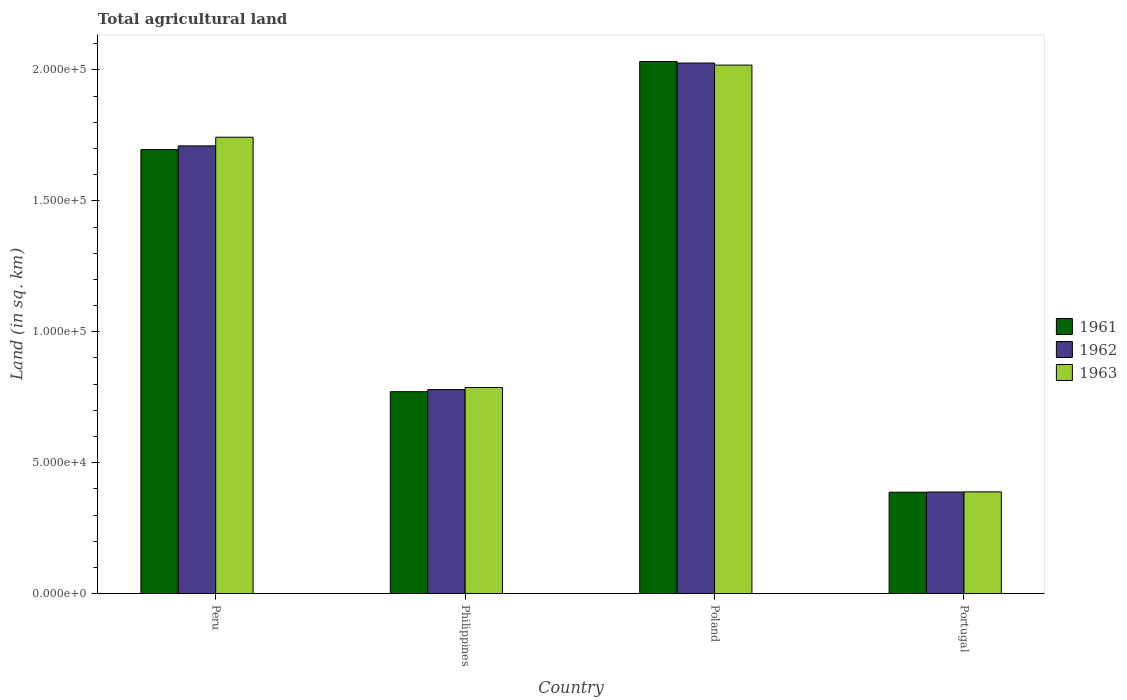How many different coloured bars are there?
Your answer should be very brief. 3. How many groups of bars are there?
Provide a succinct answer. 4. How many bars are there on the 3rd tick from the left?
Offer a terse response. 3. How many bars are there on the 4th tick from the right?
Keep it short and to the point. 3. What is the label of the 4th group of bars from the left?
Offer a very short reply. Portugal. In how many cases, is the number of bars for a given country not equal to the number of legend labels?
Ensure brevity in your answer.  0. What is the total agricultural land in 1963 in Philippines?
Offer a very short reply. 7.87e+04. Across all countries, what is the maximum total agricultural land in 1961?
Keep it short and to the point. 2.03e+05. Across all countries, what is the minimum total agricultural land in 1963?
Make the answer very short. 3.89e+04. In which country was the total agricultural land in 1962 minimum?
Your answer should be compact. Portugal. What is the total total agricultural land in 1961 in the graph?
Offer a terse response. 4.89e+05. What is the difference between the total agricultural land in 1962 in Philippines and that in Poland?
Keep it short and to the point. -1.25e+05. What is the difference between the total agricultural land in 1962 in Portugal and the total agricultural land in 1961 in Philippines?
Make the answer very short. -3.83e+04. What is the average total agricultural land in 1962 per country?
Ensure brevity in your answer.  1.23e+05. What is the difference between the total agricultural land of/in 1961 and total agricultural land of/in 1962 in Philippines?
Offer a very short reply. -790. What is the ratio of the total agricultural land in 1961 in Peru to that in Philippines?
Ensure brevity in your answer.  2.2. Is the difference between the total agricultural land in 1961 in Peru and Philippines greater than the difference between the total agricultural land in 1962 in Peru and Philippines?
Make the answer very short. No. What is the difference between the highest and the second highest total agricultural land in 1961?
Offer a very short reply. 9.24e+04. What is the difference between the highest and the lowest total agricultural land in 1961?
Your response must be concise. 1.64e+05. In how many countries, is the total agricultural land in 1961 greater than the average total agricultural land in 1961 taken over all countries?
Provide a short and direct response. 2. What does the 3rd bar from the right in Portugal represents?
Provide a short and direct response. 1961. Is it the case that in every country, the sum of the total agricultural land in 1961 and total agricultural land in 1962 is greater than the total agricultural land in 1963?
Make the answer very short. Yes. How many countries are there in the graph?
Ensure brevity in your answer.  4. Does the graph contain any zero values?
Provide a short and direct response. No. Does the graph contain grids?
Your answer should be very brief. No. What is the title of the graph?
Provide a succinct answer. Total agricultural land. What is the label or title of the Y-axis?
Your answer should be compact. Land (in sq. km). What is the Land (in sq. km) in 1961 in Peru?
Provide a short and direct response. 1.70e+05. What is the Land (in sq. km) in 1962 in Peru?
Provide a short and direct response. 1.71e+05. What is the Land (in sq. km) of 1963 in Peru?
Provide a succinct answer. 1.74e+05. What is the Land (in sq. km) in 1961 in Philippines?
Your answer should be very brief. 7.71e+04. What is the Land (in sq. km) of 1962 in Philippines?
Keep it short and to the point. 7.79e+04. What is the Land (in sq. km) of 1963 in Philippines?
Give a very brief answer. 7.87e+04. What is the Land (in sq. km) of 1961 in Poland?
Make the answer very short. 2.03e+05. What is the Land (in sq. km) in 1962 in Poland?
Provide a succinct answer. 2.03e+05. What is the Land (in sq. km) in 1963 in Poland?
Ensure brevity in your answer.  2.02e+05. What is the Land (in sq. km) in 1961 in Portugal?
Offer a very short reply. 3.88e+04. What is the Land (in sq. km) of 1962 in Portugal?
Your answer should be compact. 3.88e+04. What is the Land (in sq. km) in 1963 in Portugal?
Make the answer very short. 3.89e+04. Across all countries, what is the maximum Land (in sq. km) of 1961?
Provide a short and direct response. 2.03e+05. Across all countries, what is the maximum Land (in sq. km) in 1962?
Provide a short and direct response. 2.03e+05. Across all countries, what is the maximum Land (in sq. km) of 1963?
Provide a succinct answer. 2.02e+05. Across all countries, what is the minimum Land (in sq. km) of 1961?
Provide a short and direct response. 3.88e+04. Across all countries, what is the minimum Land (in sq. km) in 1962?
Provide a short and direct response. 3.88e+04. Across all countries, what is the minimum Land (in sq. km) in 1963?
Offer a terse response. 3.89e+04. What is the total Land (in sq. km) of 1961 in the graph?
Provide a succinct answer. 4.89e+05. What is the total Land (in sq. km) in 1962 in the graph?
Offer a very short reply. 4.90e+05. What is the total Land (in sq. km) in 1963 in the graph?
Your answer should be compact. 4.94e+05. What is the difference between the Land (in sq. km) in 1961 in Peru and that in Philippines?
Provide a succinct answer. 9.24e+04. What is the difference between the Land (in sq. km) in 1962 in Peru and that in Philippines?
Your response must be concise. 9.31e+04. What is the difference between the Land (in sq. km) in 1963 in Peru and that in Philippines?
Offer a terse response. 9.56e+04. What is the difference between the Land (in sq. km) of 1961 in Peru and that in Poland?
Give a very brief answer. -3.37e+04. What is the difference between the Land (in sq. km) of 1962 in Peru and that in Poland?
Make the answer very short. -3.16e+04. What is the difference between the Land (in sq. km) of 1963 in Peru and that in Poland?
Your answer should be compact. -2.75e+04. What is the difference between the Land (in sq. km) in 1961 in Peru and that in Portugal?
Your answer should be compact. 1.31e+05. What is the difference between the Land (in sq. km) in 1962 in Peru and that in Portugal?
Keep it short and to the point. 1.32e+05. What is the difference between the Land (in sq. km) of 1963 in Peru and that in Portugal?
Your answer should be compact. 1.35e+05. What is the difference between the Land (in sq. km) in 1961 in Philippines and that in Poland?
Keep it short and to the point. -1.26e+05. What is the difference between the Land (in sq. km) of 1962 in Philippines and that in Poland?
Provide a succinct answer. -1.25e+05. What is the difference between the Land (in sq. km) in 1963 in Philippines and that in Poland?
Ensure brevity in your answer.  -1.23e+05. What is the difference between the Land (in sq. km) in 1961 in Philippines and that in Portugal?
Keep it short and to the point. 3.84e+04. What is the difference between the Land (in sq. km) of 1962 in Philippines and that in Portugal?
Offer a very short reply. 3.91e+04. What is the difference between the Land (in sq. km) in 1963 in Philippines and that in Portugal?
Your response must be concise. 3.98e+04. What is the difference between the Land (in sq. km) in 1961 in Poland and that in Portugal?
Your answer should be very brief. 1.64e+05. What is the difference between the Land (in sq. km) in 1962 in Poland and that in Portugal?
Make the answer very short. 1.64e+05. What is the difference between the Land (in sq. km) in 1963 in Poland and that in Portugal?
Make the answer very short. 1.63e+05. What is the difference between the Land (in sq. km) of 1961 in Peru and the Land (in sq. km) of 1962 in Philippines?
Your response must be concise. 9.16e+04. What is the difference between the Land (in sq. km) in 1961 in Peru and the Land (in sq. km) in 1963 in Philippines?
Offer a terse response. 9.08e+04. What is the difference between the Land (in sq. km) in 1962 in Peru and the Land (in sq. km) in 1963 in Philippines?
Your answer should be very brief. 9.23e+04. What is the difference between the Land (in sq. km) of 1961 in Peru and the Land (in sq. km) of 1962 in Poland?
Give a very brief answer. -3.31e+04. What is the difference between the Land (in sq. km) in 1961 in Peru and the Land (in sq. km) in 1963 in Poland?
Your answer should be compact. -3.23e+04. What is the difference between the Land (in sq. km) in 1962 in Peru and the Land (in sq. km) in 1963 in Poland?
Offer a very short reply. -3.08e+04. What is the difference between the Land (in sq. km) of 1961 in Peru and the Land (in sq. km) of 1962 in Portugal?
Provide a succinct answer. 1.31e+05. What is the difference between the Land (in sq. km) in 1961 in Peru and the Land (in sq. km) in 1963 in Portugal?
Give a very brief answer. 1.31e+05. What is the difference between the Land (in sq. km) in 1962 in Peru and the Land (in sq. km) in 1963 in Portugal?
Give a very brief answer. 1.32e+05. What is the difference between the Land (in sq. km) in 1961 in Philippines and the Land (in sq. km) in 1962 in Poland?
Keep it short and to the point. -1.25e+05. What is the difference between the Land (in sq. km) of 1961 in Philippines and the Land (in sq. km) of 1963 in Poland?
Keep it short and to the point. -1.25e+05. What is the difference between the Land (in sq. km) of 1962 in Philippines and the Land (in sq. km) of 1963 in Poland?
Provide a succinct answer. -1.24e+05. What is the difference between the Land (in sq. km) of 1961 in Philippines and the Land (in sq. km) of 1962 in Portugal?
Give a very brief answer. 3.83e+04. What is the difference between the Land (in sq. km) in 1961 in Philippines and the Land (in sq. km) in 1963 in Portugal?
Your answer should be compact. 3.83e+04. What is the difference between the Land (in sq. km) in 1962 in Philippines and the Land (in sq. km) in 1963 in Portugal?
Give a very brief answer. 3.90e+04. What is the difference between the Land (in sq. km) in 1961 in Poland and the Land (in sq. km) in 1962 in Portugal?
Your answer should be very brief. 1.64e+05. What is the difference between the Land (in sq. km) in 1961 in Poland and the Land (in sq. km) in 1963 in Portugal?
Your answer should be compact. 1.64e+05. What is the difference between the Land (in sq. km) in 1962 in Poland and the Land (in sq. km) in 1963 in Portugal?
Your answer should be very brief. 1.64e+05. What is the average Land (in sq. km) in 1961 per country?
Your answer should be very brief. 1.22e+05. What is the average Land (in sq. km) of 1962 per country?
Make the answer very short. 1.23e+05. What is the average Land (in sq. km) in 1963 per country?
Provide a succinct answer. 1.23e+05. What is the difference between the Land (in sq. km) of 1961 and Land (in sq. km) of 1962 in Peru?
Make the answer very short. -1430. What is the difference between the Land (in sq. km) in 1961 and Land (in sq. km) in 1963 in Peru?
Ensure brevity in your answer.  -4740. What is the difference between the Land (in sq. km) of 1962 and Land (in sq. km) of 1963 in Peru?
Keep it short and to the point. -3310. What is the difference between the Land (in sq. km) in 1961 and Land (in sq. km) in 1962 in Philippines?
Keep it short and to the point. -790. What is the difference between the Land (in sq. km) of 1961 and Land (in sq. km) of 1963 in Philippines?
Your answer should be compact. -1590. What is the difference between the Land (in sq. km) of 1962 and Land (in sq. km) of 1963 in Philippines?
Your answer should be very brief. -800. What is the difference between the Land (in sq. km) of 1961 and Land (in sq. km) of 1962 in Poland?
Your response must be concise. 600. What is the difference between the Land (in sq. km) of 1961 and Land (in sq. km) of 1963 in Poland?
Your response must be concise. 1380. What is the difference between the Land (in sq. km) of 1962 and Land (in sq. km) of 1963 in Poland?
Keep it short and to the point. 780. What is the difference between the Land (in sq. km) of 1961 and Land (in sq. km) of 1962 in Portugal?
Ensure brevity in your answer.  -60. What is the difference between the Land (in sq. km) of 1961 and Land (in sq. km) of 1963 in Portugal?
Your answer should be compact. -120. What is the difference between the Land (in sq. km) of 1962 and Land (in sq. km) of 1963 in Portugal?
Your response must be concise. -60. What is the ratio of the Land (in sq. km) of 1961 in Peru to that in Philippines?
Make the answer very short. 2.2. What is the ratio of the Land (in sq. km) in 1962 in Peru to that in Philippines?
Ensure brevity in your answer.  2.19. What is the ratio of the Land (in sq. km) in 1963 in Peru to that in Philippines?
Keep it short and to the point. 2.21. What is the ratio of the Land (in sq. km) in 1961 in Peru to that in Poland?
Give a very brief answer. 0.83. What is the ratio of the Land (in sq. km) of 1962 in Peru to that in Poland?
Give a very brief answer. 0.84. What is the ratio of the Land (in sq. km) of 1963 in Peru to that in Poland?
Keep it short and to the point. 0.86. What is the ratio of the Land (in sq. km) of 1961 in Peru to that in Portugal?
Your answer should be very brief. 4.38. What is the ratio of the Land (in sq. km) of 1962 in Peru to that in Portugal?
Offer a very short reply. 4.41. What is the ratio of the Land (in sq. km) in 1963 in Peru to that in Portugal?
Your answer should be very brief. 4.48. What is the ratio of the Land (in sq. km) of 1961 in Philippines to that in Poland?
Offer a very short reply. 0.38. What is the ratio of the Land (in sq. km) of 1962 in Philippines to that in Poland?
Offer a very short reply. 0.38. What is the ratio of the Land (in sq. km) of 1963 in Philippines to that in Poland?
Your answer should be compact. 0.39. What is the ratio of the Land (in sq. km) in 1961 in Philippines to that in Portugal?
Provide a short and direct response. 1.99. What is the ratio of the Land (in sq. km) in 1962 in Philippines to that in Portugal?
Give a very brief answer. 2.01. What is the ratio of the Land (in sq. km) in 1963 in Philippines to that in Portugal?
Your answer should be compact. 2.03. What is the ratio of the Land (in sq. km) of 1961 in Poland to that in Portugal?
Your answer should be very brief. 5.24. What is the ratio of the Land (in sq. km) in 1962 in Poland to that in Portugal?
Give a very brief answer. 5.22. What is the ratio of the Land (in sq. km) of 1963 in Poland to that in Portugal?
Keep it short and to the point. 5.19. What is the difference between the highest and the second highest Land (in sq. km) in 1961?
Ensure brevity in your answer.  3.37e+04. What is the difference between the highest and the second highest Land (in sq. km) in 1962?
Make the answer very short. 3.16e+04. What is the difference between the highest and the second highest Land (in sq. km) of 1963?
Your answer should be very brief. 2.75e+04. What is the difference between the highest and the lowest Land (in sq. km) in 1961?
Keep it short and to the point. 1.64e+05. What is the difference between the highest and the lowest Land (in sq. km) of 1962?
Keep it short and to the point. 1.64e+05. What is the difference between the highest and the lowest Land (in sq. km) in 1963?
Provide a short and direct response. 1.63e+05. 